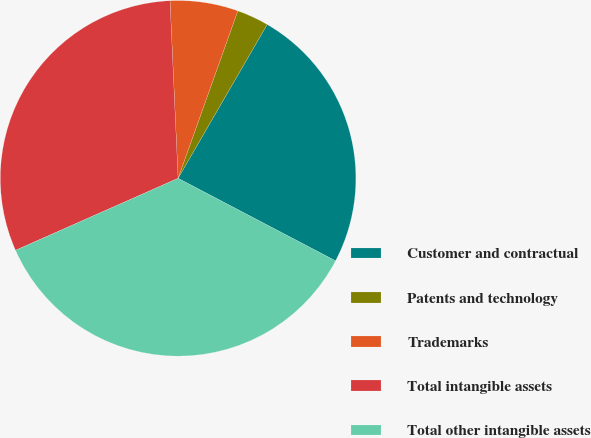Convert chart. <chart><loc_0><loc_0><loc_500><loc_500><pie_chart><fcel>Customer and contractual<fcel>Patents and technology<fcel>Trademarks<fcel>Total intangible assets<fcel>Total other intangible assets<nl><fcel>24.33%<fcel>2.9%<fcel>6.18%<fcel>30.91%<fcel>35.68%<nl></chart> 